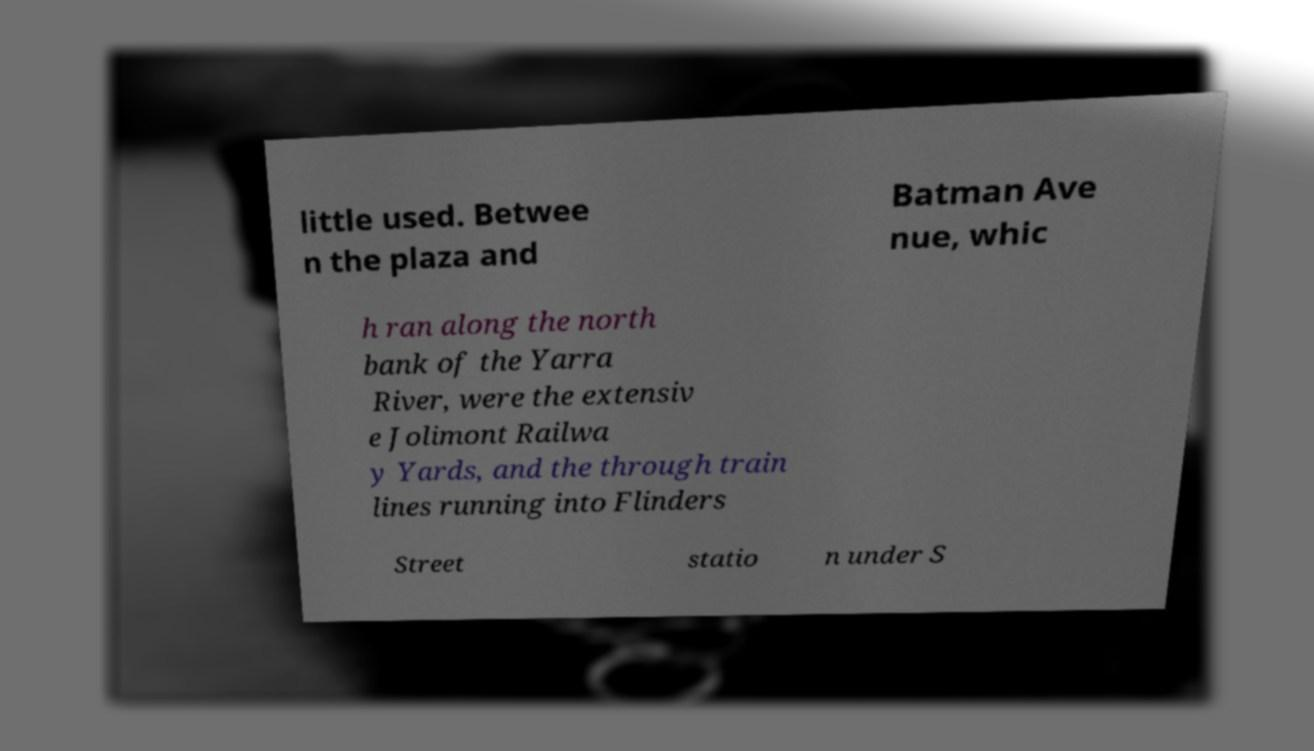Please read and relay the text visible in this image. What does it say? little used. Betwee n the plaza and Batman Ave nue, whic h ran along the north bank of the Yarra River, were the extensiv e Jolimont Railwa y Yards, and the through train lines running into Flinders Street statio n under S 